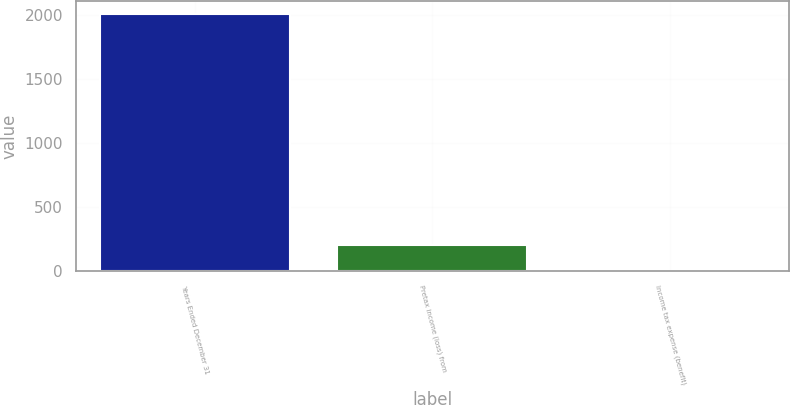Convert chart. <chart><loc_0><loc_0><loc_500><loc_500><bar_chart><fcel>Years Ended December 31<fcel>Pretax income (loss) from<fcel>Income tax expense (benefit)<nl><fcel>2007<fcel>201.6<fcel>1<nl></chart> 